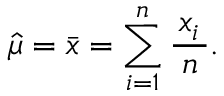<formula> <loc_0><loc_0><loc_500><loc_500>{ \widehat { \mu } } = { \bar { x } } = \sum _ { i = 1 } ^ { n } { \frac { \, x _ { i } \, } { n } } .</formula> 